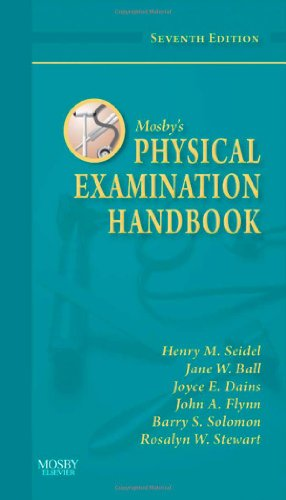Who is the author of this book? The book, Mosby's Physical Examination Handbook, 7e, lists multiple authors including Henry M. Seidel MD, Jane W. Ball, Joyce E. Dains, John A. Flynn, Barry S. Solomon, Rosalyn W. Stewart. 